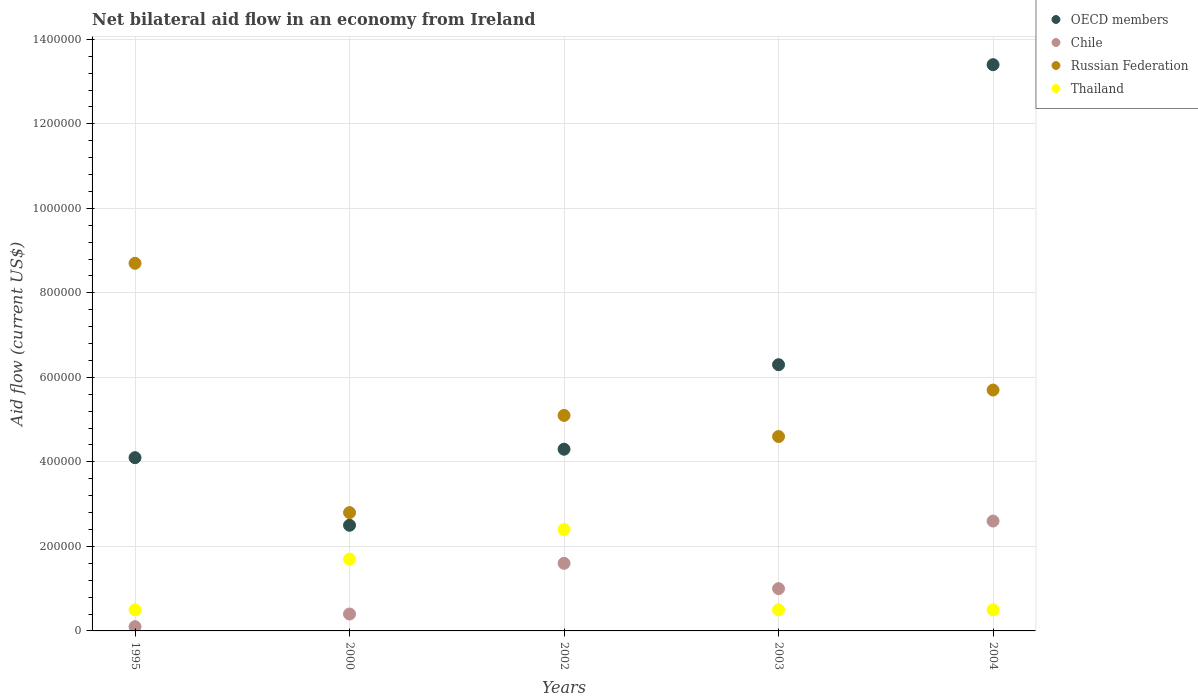How many different coloured dotlines are there?
Ensure brevity in your answer.  4. Is the number of dotlines equal to the number of legend labels?
Give a very brief answer. Yes. What is the net bilateral aid flow in Thailand in 2004?
Give a very brief answer. 5.00e+04. Across all years, what is the minimum net bilateral aid flow in OECD members?
Give a very brief answer. 2.50e+05. In which year was the net bilateral aid flow in OECD members maximum?
Provide a succinct answer. 2004. In which year was the net bilateral aid flow in OECD members minimum?
Make the answer very short. 2000. What is the total net bilateral aid flow in Thailand in the graph?
Your response must be concise. 5.60e+05. What is the difference between the net bilateral aid flow in Chile in 2002 and that in 2004?
Provide a succinct answer. -1.00e+05. What is the average net bilateral aid flow in Russian Federation per year?
Offer a very short reply. 5.38e+05. In the year 2000, what is the difference between the net bilateral aid flow in Russian Federation and net bilateral aid flow in Chile?
Your answer should be compact. 2.40e+05. In how many years, is the net bilateral aid flow in Russian Federation greater than 680000 US$?
Your answer should be compact. 1. Is the net bilateral aid flow in Russian Federation in 2002 less than that in 2004?
Your answer should be very brief. Yes. Is the difference between the net bilateral aid flow in Russian Federation in 2003 and 2004 greater than the difference between the net bilateral aid flow in Chile in 2003 and 2004?
Ensure brevity in your answer.  Yes. What is the difference between the highest and the lowest net bilateral aid flow in OECD members?
Ensure brevity in your answer.  1.09e+06. Is the sum of the net bilateral aid flow in Thailand in 2003 and 2004 greater than the maximum net bilateral aid flow in Chile across all years?
Offer a very short reply. No. Is it the case that in every year, the sum of the net bilateral aid flow in Thailand and net bilateral aid flow in Chile  is greater than the sum of net bilateral aid flow in OECD members and net bilateral aid flow in Russian Federation?
Your answer should be very brief. No. Is the net bilateral aid flow in Chile strictly less than the net bilateral aid flow in OECD members over the years?
Your answer should be very brief. Yes. How many years are there in the graph?
Ensure brevity in your answer.  5. Are the values on the major ticks of Y-axis written in scientific E-notation?
Provide a short and direct response. No. Does the graph contain any zero values?
Offer a very short reply. No. Does the graph contain grids?
Make the answer very short. Yes. Where does the legend appear in the graph?
Your response must be concise. Top right. How are the legend labels stacked?
Offer a very short reply. Vertical. What is the title of the graph?
Your response must be concise. Net bilateral aid flow in an economy from Ireland. What is the label or title of the Y-axis?
Keep it short and to the point. Aid flow (current US$). What is the Aid flow (current US$) in Russian Federation in 1995?
Make the answer very short. 8.70e+05. What is the Aid flow (current US$) of OECD members in 2000?
Your answer should be compact. 2.50e+05. What is the Aid flow (current US$) of Chile in 2000?
Give a very brief answer. 4.00e+04. What is the Aid flow (current US$) of OECD members in 2002?
Give a very brief answer. 4.30e+05. What is the Aid flow (current US$) in Chile in 2002?
Offer a terse response. 1.60e+05. What is the Aid flow (current US$) in Russian Federation in 2002?
Offer a terse response. 5.10e+05. What is the Aid flow (current US$) of OECD members in 2003?
Offer a very short reply. 6.30e+05. What is the Aid flow (current US$) in Chile in 2003?
Your answer should be compact. 1.00e+05. What is the Aid flow (current US$) in OECD members in 2004?
Provide a short and direct response. 1.34e+06. What is the Aid flow (current US$) in Chile in 2004?
Provide a succinct answer. 2.60e+05. What is the Aid flow (current US$) in Russian Federation in 2004?
Keep it short and to the point. 5.70e+05. What is the Aid flow (current US$) of Thailand in 2004?
Offer a very short reply. 5.00e+04. Across all years, what is the maximum Aid flow (current US$) of OECD members?
Offer a very short reply. 1.34e+06. Across all years, what is the maximum Aid flow (current US$) in Chile?
Make the answer very short. 2.60e+05. Across all years, what is the maximum Aid flow (current US$) in Russian Federation?
Your response must be concise. 8.70e+05. Across all years, what is the maximum Aid flow (current US$) of Thailand?
Offer a terse response. 2.40e+05. Across all years, what is the minimum Aid flow (current US$) of Thailand?
Your answer should be very brief. 5.00e+04. What is the total Aid flow (current US$) in OECD members in the graph?
Provide a succinct answer. 3.06e+06. What is the total Aid flow (current US$) of Chile in the graph?
Offer a terse response. 5.70e+05. What is the total Aid flow (current US$) of Russian Federation in the graph?
Offer a terse response. 2.69e+06. What is the total Aid flow (current US$) of Thailand in the graph?
Your response must be concise. 5.60e+05. What is the difference between the Aid flow (current US$) in Chile in 1995 and that in 2000?
Provide a short and direct response. -3.00e+04. What is the difference between the Aid flow (current US$) of Russian Federation in 1995 and that in 2000?
Keep it short and to the point. 5.90e+05. What is the difference between the Aid flow (current US$) in Thailand in 1995 and that in 2002?
Your response must be concise. -1.90e+05. What is the difference between the Aid flow (current US$) in OECD members in 1995 and that in 2003?
Your answer should be compact. -2.20e+05. What is the difference between the Aid flow (current US$) in Russian Federation in 1995 and that in 2003?
Make the answer very short. 4.10e+05. What is the difference between the Aid flow (current US$) in Thailand in 1995 and that in 2003?
Your answer should be compact. 0. What is the difference between the Aid flow (current US$) of OECD members in 1995 and that in 2004?
Provide a short and direct response. -9.30e+05. What is the difference between the Aid flow (current US$) in Russian Federation in 1995 and that in 2004?
Keep it short and to the point. 3.00e+05. What is the difference between the Aid flow (current US$) in Thailand in 1995 and that in 2004?
Ensure brevity in your answer.  0. What is the difference between the Aid flow (current US$) of Chile in 2000 and that in 2002?
Make the answer very short. -1.20e+05. What is the difference between the Aid flow (current US$) in Russian Federation in 2000 and that in 2002?
Your answer should be very brief. -2.30e+05. What is the difference between the Aid flow (current US$) in OECD members in 2000 and that in 2003?
Your answer should be compact. -3.80e+05. What is the difference between the Aid flow (current US$) of OECD members in 2000 and that in 2004?
Your answer should be compact. -1.09e+06. What is the difference between the Aid flow (current US$) of Chile in 2000 and that in 2004?
Keep it short and to the point. -2.20e+05. What is the difference between the Aid flow (current US$) of Russian Federation in 2000 and that in 2004?
Provide a succinct answer. -2.90e+05. What is the difference between the Aid flow (current US$) in OECD members in 2002 and that in 2003?
Give a very brief answer. -2.00e+05. What is the difference between the Aid flow (current US$) in Chile in 2002 and that in 2003?
Ensure brevity in your answer.  6.00e+04. What is the difference between the Aid flow (current US$) of Thailand in 2002 and that in 2003?
Provide a succinct answer. 1.90e+05. What is the difference between the Aid flow (current US$) of OECD members in 2002 and that in 2004?
Provide a succinct answer. -9.10e+05. What is the difference between the Aid flow (current US$) of Russian Federation in 2002 and that in 2004?
Your response must be concise. -6.00e+04. What is the difference between the Aid flow (current US$) in Thailand in 2002 and that in 2004?
Give a very brief answer. 1.90e+05. What is the difference between the Aid flow (current US$) of OECD members in 2003 and that in 2004?
Provide a succinct answer. -7.10e+05. What is the difference between the Aid flow (current US$) in Russian Federation in 2003 and that in 2004?
Make the answer very short. -1.10e+05. What is the difference between the Aid flow (current US$) of OECD members in 1995 and the Aid flow (current US$) of Russian Federation in 2000?
Provide a succinct answer. 1.30e+05. What is the difference between the Aid flow (current US$) of OECD members in 1995 and the Aid flow (current US$) of Thailand in 2000?
Provide a short and direct response. 2.40e+05. What is the difference between the Aid flow (current US$) of Chile in 1995 and the Aid flow (current US$) of Russian Federation in 2000?
Keep it short and to the point. -2.70e+05. What is the difference between the Aid flow (current US$) of Russian Federation in 1995 and the Aid flow (current US$) of Thailand in 2000?
Your answer should be compact. 7.00e+05. What is the difference between the Aid flow (current US$) in OECD members in 1995 and the Aid flow (current US$) in Thailand in 2002?
Give a very brief answer. 1.70e+05. What is the difference between the Aid flow (current US$) of Chile in 1995 and the Aid flow (current US$) of Russian Federation in 2002?
Your answer should be very brief. -5.00e+05. What is the difference between the Aid flow (current US$) in Chile in 1995 and the Aid flow (current US$) in Thailand in 2002?
Offer a terse response. -2.30e+05. What is the difference between the Aid flow (current US$) of Russian Federation in 1995 and the Aid flow (current US$) of Thailand in 2002?
Provide a succinct answer. 6.30e+05. What is the difference between the Aid flow (current US$) in OECD members in 1995 and the Aid flow (current US$) in Thailand in 2003?
Your answer should be compact. 3.60e+05. What is the difference between the Aid flow (current US$) of Chile in 1995 and the Aid flow (current US$) of Russian Federation in 2003?
Make the answer very short. -4.50e+05. What is the difference between the Aid flow (current US$) in Russian Federation in 1995 and the Aid flow (current US$) in Thailand in 2003?
Make the answer very short. 8.20e+05. What is the difference between the Aid flow (current US$) of OECD members in 1995 and the Aid flow (current US$) of Chile in 2004?
Your answer should be very brief. 1.50e+05. What is the difference between the Aid flow (current US$) in OECD members in 1995 and the Aid flow (current US$) in Russian Federation in 2004?
Offer a terse response. -1.60e+05. What is the difference between the Aid flow (current US$) in Chile in 1995 and the Aid flow (current US$) in Russian Federation in 2004?
Make the answer very short. -5.60e+05. What is the difference between the Aid flow (current US$) of Russian Federation in 1995 and the Aid flow (current US$) of Thailand in 2004?
Provide a short and direct response. 8.20e+05. What is the difference between the Aid flow (current US$) in OECD members in 2000 and the Aid flow (current US$) in Chile in 2002?
Make the answer very short. 9.00e+04. What is the difference between the Aid flow (current US$) of OECD members in 2000 and the Aid flow (current US$) of Thailand in 2002?
Make the answer very short. 10000. What is the difference between the Aid flow (current US$) in Chile in 2000 and the Aid flow (current US$) in Russian Federation in 2002?
Offer a very short reply. -4.70e+05. What is the difference between the Aid flow (current US$) of Russian Federation in 2000 and the Aid flow (current US$) of Thailand in 2002?
Offer a very short reply. 4.00e+04. What is the difference between the Aid flow (current US$) of Chile in 2000 and the Aid flow (current US$) of Russian Federation in 2003?
Your answer should be very brief. -4.20e+05. What is the difference between the Aid flow (current US$) of Russian Federation in 2000 and the Aid flow (current US$) of Thailand in 2003?
Your response must be concise. 2.30e+05. What is the difference between the Aid flow (current US$) in OECD members in 2000 and the Aid flow (current US$) in Russian Federation in 2004?
Provide a succinct answer. -3.20e+05. What is the difference between the Aid flow (current US$) in Chile in 2000 and the Aid flow (current US$) in Russian Federation in 2004?
Make the answer very short. -5.30e+05. What is the difference between the Aid flow (current US$) of OECD members in 2002 and the Aid flow (current US$) of Chile in 2003?
Offer a terse response. 3.30e+05. What is the difference between the Aid flow (current US$) of OECD members in 2002 and the Aid flow (current US$) of Thailand in 2003?
Make the answer very short. 3.80e+05. What is the difference between the Aid flow (current US$) of Chile in 2002 and the Aid flow (current US$) of Russian Federation in 2003?
Make the answer very short. -3.00e+05. What is the difference between the Aid flow (current US$) of Chile in 2002 and the Aid flow (current US$) of Thailand in 2003?
Keep it short and to the point. 1.10e+05. What is the difference between the Aid flow (current US$) of OECD members in 2002 and the Aid flow (current US$) of Russian Federation in 2004?
Offer a terse response. -1.40e+05. What is the difference between the Aid flow (current US$) of Chile in 2002 and the Aid flow (current US$) of Russian Federation in 2004?
Provide a short and direct response. -4.10e+05. What is the difference between the Aid flow (current US$) in Chile in 2002 and the Aid flow (current US$) in Thailand in 2004?
Your response must be concise. 1.10e+05. What is the difference between the Aid flow (current US$) in OECD members in 2003 and the Aid flow (current US$) in Thailand in 2004?
Offer a very short reply. 5.80e+05. What is the difference between the Aid flow (current US$) of Chile in 2003 and the Aid flow (current US$) of Russian Federation in 2004?
Offer a very short reply. -4.70e+05. What is the difference between the Aid flow (current US$) in Chile in 2003 and the Aid flow (current US$) in Thailand in 2004?
Ensure brevity in your answer.  5.00e+04. What is the difference between the Aid flow (current US$) of Russian Federation in 2003 and the Aid flow (current US$) of Thailand in 2004?
Your response must be concise. 4.10e+05. What is the average Aid flow (current US$) of OECD members per year?
Give a very brief answer. 6.12e+05. What is the average Aid flow (current US$) in Chile per year?
Provide a short and direct response. 1.14e+05. What is the average Aid flow (current US$) of Russian Federation per year?
Offer a very short reply. 5.38e+05. What is the average Aid flow (current US$) in Thailand per year?
Ensure brevity in your answer.  1.12e+05. In the year 1995, what is the difference between the Aid flow (current US$) in OECD members and Aid flow (current US$) in Russian Federation?
Your response must be concise. -4.60e+05. In the year 1995, what is the difference between the Aid flow (current US$) in OECD members and Aid flow (current US$) in Thailand?
Ensure brevity in your answer.  3.60e+05. In the year 1995, what is the difference between the Aid flow (current US$) of Chile and Aid flow (current US$) of Russian Federation?
Give a very brief answer. -8.60e+05. In the year 1995, what is the difference between the Aid flow (current US$) in Chile and Aid flow (current US$) in Thailand?
Your answer should be very brief. -4.00e+04. In the year 1995, what is the difference between the Aid flow (current US$) in Russian Federation and Aid flow (current US$) in Thailand?
Provide a short and direct response. 8.20e+05. In the year 2000, what is the difference between the Aid flow (current US$) of OECD members and Aid flow (current US$) of Chile?
Your response must be concise. 2.10e+05. In the year 2000, what is the difference between the Aid flow (current US$) of OECD members and Aid flow (current US$) of Russian Federation?
Your answer should be very brief. -3.00e+04. In the year 2002, what is the difference between the Aid flow (current US$) in OECD members and Aid flow (current US$) in Chile?
Ensure brevity in your answer.  2.70e+05. In the year 2002, what is the difference between the Aid flow (current US$) in Chile and Aid flow (current US$) in Russian Federation?
Make the answer very short. -3.50e+05. In the year 2002, what is the difference between the Aid flow (current US$) in Russian Federation and Aid flow (current US$) in Thailand?
Your answer should be compact. 2.70e+05. In the year 2003, what is the difference between the Aid flow (current US$) of OECD members and Aid flow (current US$) of Chile?
Keep it short and to the point. 5.30e+05. In the year 2003, what is the difference between the Aid flow (current US$) in OECD members and Aid flow (current US$) in Russian Federation?
Keep it short and to the point. 1.70e+05. In the year 2003, what is the difference between the Aid flow (current US$) in OECD members and Aid flow (current US$) in Thailand?
Your response must be concise. 5.80e+05. In the year 2003, what is the difference between the Aid flow (current US$) of Chile and Aid flow (current US$) of Russian Federation?
Give a very brief answer. -3.60e+05. In the year 2003, what is the difference between the Aid flow (current US$) in Chile and Aid flow (current US$) in Thailand?
Your answer should be very brief. 5.00e+04. In the year 2004, what is the difference between the Aid flow (current US$) in OECD members and Aid flow (current US$) in Chile?
Offer a very short reply. 1.08e+06. In the year 2004, what is the difference between the Aid flow (current US$) in OECD members and Aid flow (current US$) in Russian Federation?
Provide a short and direct response. 7.70e+05. In the year 2004, what is the difference between the Aid flow (current US$) of OECD members and Aid flow (current US$) of Thailand?
Offer a terse response. 1.29e+06. In the year 2004, what is the difference between the Aid flow (current US$) of Chile and Aid flow (current US$) of Russian Federation?
Your answer should be very brief. -3.10e+05. In the year 2004, what is the difference between the Aid flow (current US$) in Russian Federation and Aid flow (current US$) in Thailand?
Make the answer very short. 5.20e+05. What is the ratio of the Aid flow (current US$) of OECD members in 1995 to that in 2000?
Your answer should be very brief. 1.64. What is the ratio of the Aid flow (current US$) of Russian Federation in 1995 to that in 2000?
Give a very brief answer. 3.11. What is the ratio of the Aid flow (current US$) in Thailand in 1995 to that in 2000?
Give a very brief answer. 0.29. What is the ratio of the Aid flow (current US$) of OECD members in 1995 to that in 2002?
Offer a very short reply. 0.95. What is the ratio of the Aid flow (current US$) in Chile in 1995 to that in 2002?
Keep it short and to the point. 0.06. What is the ratio of the Aid flow (current US$) in Russian Federation in 1995 to that in 2002?
Keep it short and to the point. 1.71. What is the ratio of the Aid flow (current US$) in Thailand in 1995 to that in 2002?
Offer a very short reply. 0.21. What is the ratio of the Aid flow (current US$) of OECD members in 1995 to that in 2003?
Make the answer very short. 0.65. What is the ratio of the Aid flow (current US$) of Russian Federation in 1995 to that in 2003?
Provide a succinct answer. 1.89. What is the ratio of the Aid flow (current US$) in Thailand in 1995 to that in 2003?
Provide a short and direct response. 1. What is the ratio of the Aid flow (current US$) in OECD members in 1995 to that in 2004?
Provide a succinct answer. 0.31. What is the ratio of the Aid flow (current US$) in Chile in 1995 to that in 2004?
Provide a succinct answer. 0.04. What is the ratio of the Aid flow (current US$) of Russian Federation in 1995 to that in 2004?
Offer a very short reply. 1.53. What is the ratio of the Aid flow (current US$) in OECD members in 2000 to that in 2002?
Keep it short and to the point. 0.58. What is the ratio of the Aid flow (current US$) of Chile in 2000 to that in 2002?
Offer a very short reply. 0.25. What is the ratio of the Aid flow (current US$) in Russian Federation in 2000 to that in 2002?
Provide a succinct answer. 0.55. What is the ratio of the Aid flow (current US$) in Thailand in 2000 to that in 2002?
Ensure brevity in your answer.  0.71. What is the ratio of the Aid flow (current US$) of OECD members in 2000 to that in 2003?
Provide a succinct answer. 0.4. What is the ratio of the Aid flow (current US$) of Chile in 2000 to that in 2003?
Ensure brevity in your answer.  0.4. What is the ratio of the Aid flow (current US$) in Russian Federation in 2000 to that in 2003?
Make the answer very short. 0.61. What is the ratio of the Aid flow (current US$) of Thailand in 2000 to that in 2003?
Your answer should be very brief. 3.4. What is the ratio of the Aid flow (current US$) in OECD members in 2000 to that in 2004?
Make the answer very short. 0.19. What is the ratio of the Aid flow (current US$) in Chile in 2000 to that in 2004?
Offer a terse response. 0.15. What is the ratio of the Aid flow (current US$) of Russian Federation in 2000 to that in 2004?
Offer a terse response. 0.49. What is the ratio of the Aid flow (current US$) in OECD members in 2002 to that in 2003?
Your response must be concise. 0.68. What is the ratio of the Aid flow (current US$) of Russian Federation in 2002 to that in 2003?
Give a very brief answer. 1.11. What is the ratio of the Aid flow (current US$) of OECD members in 2002 to that in 2004?
Give a very brief answer. 0.32. What is the ratio of the Aid flow (current US$) of Chile in 2002 to that in 2004?
Your answer should be very brief. 0.62. What is the ratio of the Aid flow (current US$) in Russian Federation in 2002 to that in 2004?
Provide a short and direct response. 0.89. What is the ratio of the Aid flow (current US$) in OECD members in 2003 to that in 2004?
Your response must be concise. 0.47. What is the ratio of the Aid flow (current US$) in Chile in 2003 to that in 2004?
Give a very brief answer. 0.38. What is the ratio of the Aid flow (current US$) in Russian Federation in 2003 to that in 2004?
Make the answer very short. 0.81. What is the ratio of the Aid flow (current US$) in Thailand in 2003 to that in 2004?
Your answer should be very brief. 1. What is the difference between the highest and the second highest Aid flow (current US$) in OECD members?
Keep it short and to the point. 7.10e+05. What is the difference between the highest and the second highest Aid flow (current US$) in Chile?
Give a very brief answer. 1.00e+05. What is the difference between the highest and the second highest Aid flow (current US$) in Russian Federation?
Your answer should be compact. 3.00e+05. What is the difference between the highest and the lowest Aid flow (current US$) in OECD members?
Your response must be concise. 1.09e+06. What is the difference between the highest and the lowest Aid flow (current US$) in Russian Federation?
Offer a terse response. 5.90e+05. What is the difference between the highest and the lowest Aid flow (current US$) of Thailand?
Keep it short and to the point. 1.90e+05. 